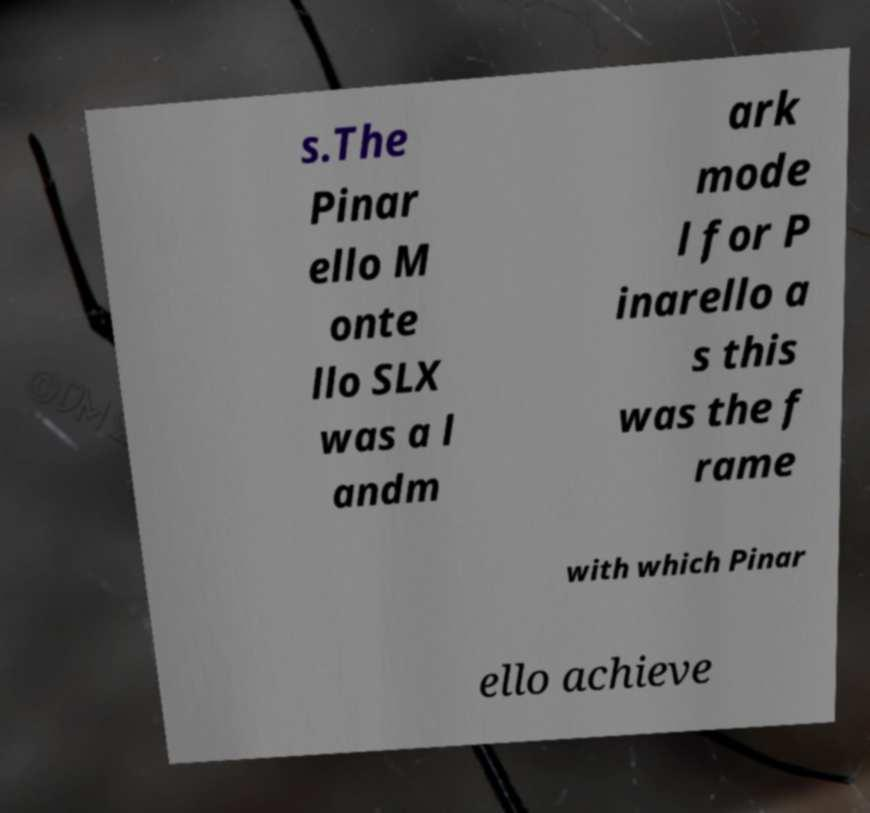I need the written content from this picture converted into text. Can you do that? s.The Pinar ello M onte llo SLX was a l andm ark mode l for P inarello a s this was the f rame with which Pinar ello achieve 